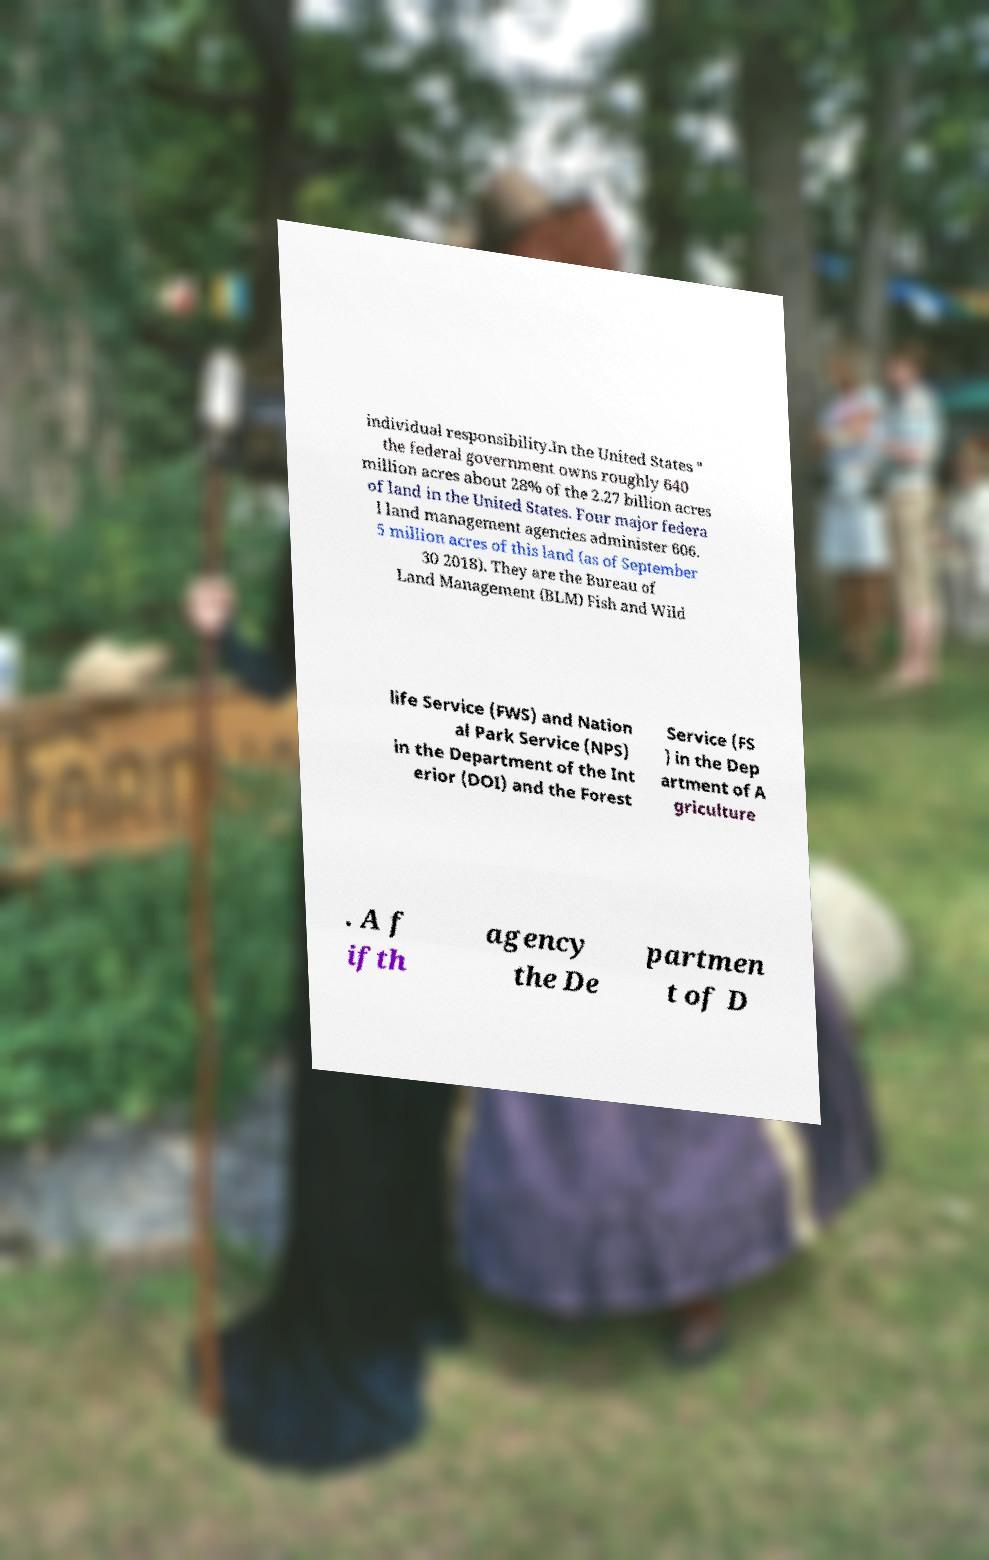Could you assist in decoding the text presented in this image and type it out clearly? individual responsibility.In the United States " the federal government owns roughly 640 million acres about 28% of the 2.27 billion acres of land in the United States. Four major federa l land management agencies administer 606. 5 million acres of this land (as of September 30 2018). They are the Bureau of Land Management (BLM) Fish and Wild life Service (FWS) and Nation al Park Service (NPS) in the Department of the Int erior (DOI) and the Forest Service (FS ) in the Dep artment of A griculture . A f ifth agency the De partmen t of D 